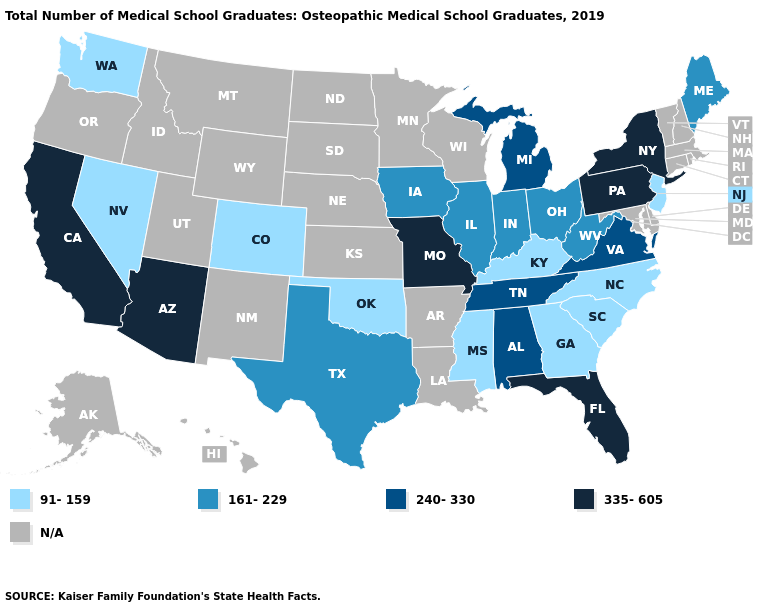What is the lowest value in states that border Arizona?
Concise answer only. 91-159. What is the lowest value in states that border Idaho?
Concise answer only. 91-159. Does the map have missing data?
Short answer required. Yes. Name the states that have a value in the range 161-229?
Give a very brief answer. Illinois, Indiana, Iowa, Maine, Ohio, Texas, West Virginia. Which states hav the highest value in the Northeast?
Keep it brief. New York, Pennsylvania. Name the states that have a value in the range N/A?
Write a very short answer. Alaska, Arkansas, Connecticut, Delaware, Hawaii, Idaho, Kansas, Louisiana, Maryland, Massachusetts, Minnesota, Montana, Nebraska, New Hampshire, New Mexico, North Dakota, Oregon, Rhode Island, South Dakota, Utah, Vermont, Wisconsin, Wyoming. Name the states that have a value in the range 335-605?
Answer briefly. Arizona, California, Florida, Missouri, New York, Pennsylvania. What is the value of Texas?
Write a very short answer. 161-229. What is the highest value in the USA?
Write a very short answer. 335-605. Among the states that border Delaware , which have the highest value?
Answer briefly. Pennsylvania. Among the states that border Indiana , does Kentucky have the lowest value?
Give a very brief answer. Yes. How many symbols are there in the legend?
Give a very brief answer. 5. Does Washington have the highest value in the West?
Keep it brief. No. Name the states that have a value in the range 161-229?
Short answer required. Illinois, Indiana, Iowa, Maine, Ohio, Texas, West Virginia. Name the states that have a value in the range N/A?
Short answer required. Alaska, Arkansas, Connecticut, Delaware, Hawaii, Idaho, Kansas, Louisiana, Maryland, Massachusetts, Minnesota, Montana, Nebraska, New Hampshire, New Mexico, North Dakota, Oregon, Rhode Island, South Dakota, Utah, Vermont, Wisconsin, Wyoming. 